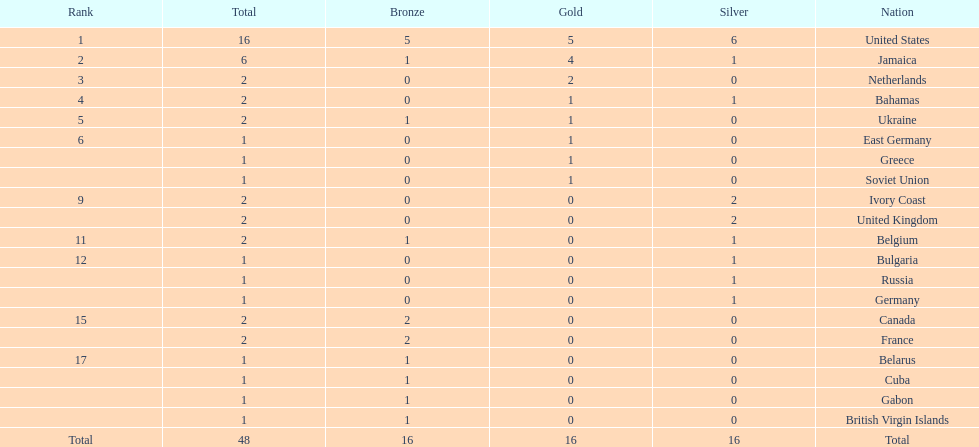Which countries won at least 3 silver medals? United States. Help me parse the entirety of this table. {'header': ['Rank', 'Total', 'Bronze', 'Gold', 'Silver', 'Nation'], 'rows': [['1', '16', '5', '5', '6', 'United States'], ['2', '6', '1', '4', '1', 'Jamaica'], ['3', '2', '0', '2', '0', 'Netherlands'], ['4', '2', '0', '1', '1', 'Bahamas'], ['5', '2', '1', '1', '0', 'Ukraine'], ['6', '1', '0', '1', '0', 'East Germany'], ['', '1', '0', '1', '0', 'Greece'], ['', '1', '0', '1', '0', 'Soviet Union'], ['9', '2', '0', '0', '2', 'Ivory Coast'], ['', '2', '0', '0', '2', 'United Kingdom'], ['11', '2', '1', '0', '1', 'Belgium'], ['12', '1', '0', '0', '1', 'Bulgaria'], ['', '1', '0', '0', '1', 'Russia'], ['', '1', '0', '0', '1', 'Germany'], ['15', '2', '2', '0', '0', 'Canada'], ['', '2', '2', '0', '0', 'France'], ['17', '1', '1', '0', '0', 'Belarus'], ['', '1', '1', '0', '0', 'Cuba'], ['', '1', '1', '0', '0', 'Gabon'], ['', '1', '1', '0', '0', 'British Virgin Islands'], ['Total', '48', '16', '16', '16', 'Total']]} 